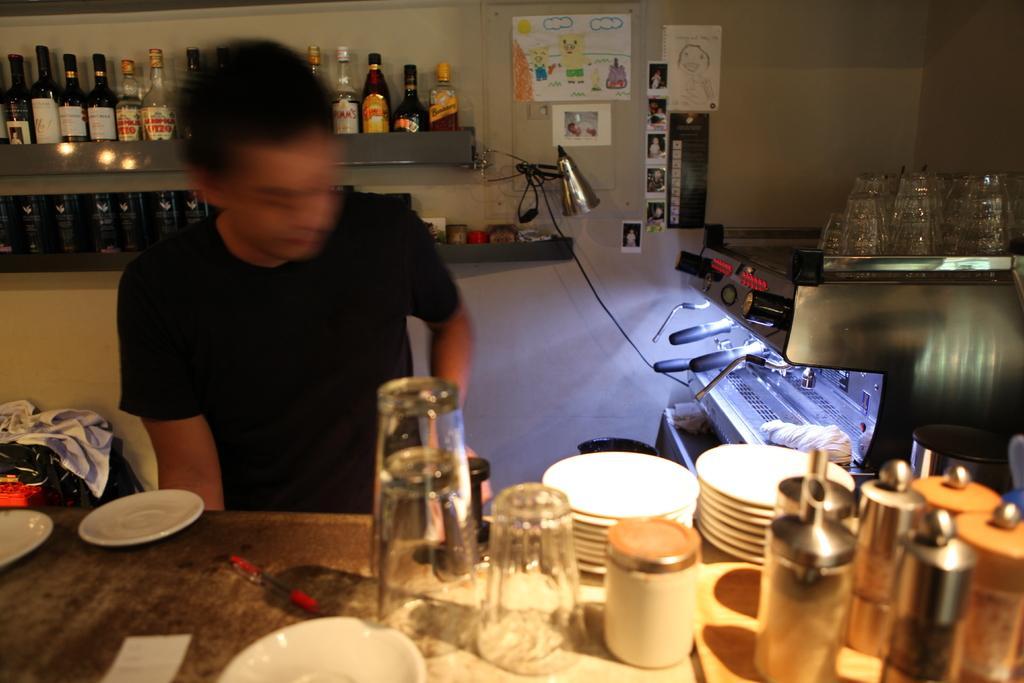How would you summarize this image in a sentence or two? In this image we can see a person sitting in front of a table on which set of glasses ,plates ,bowls a pen are placed on it. In the background we can see a machine we can see a machine on which glass items are placed. on the wall group of bottles are placed in the rack. 